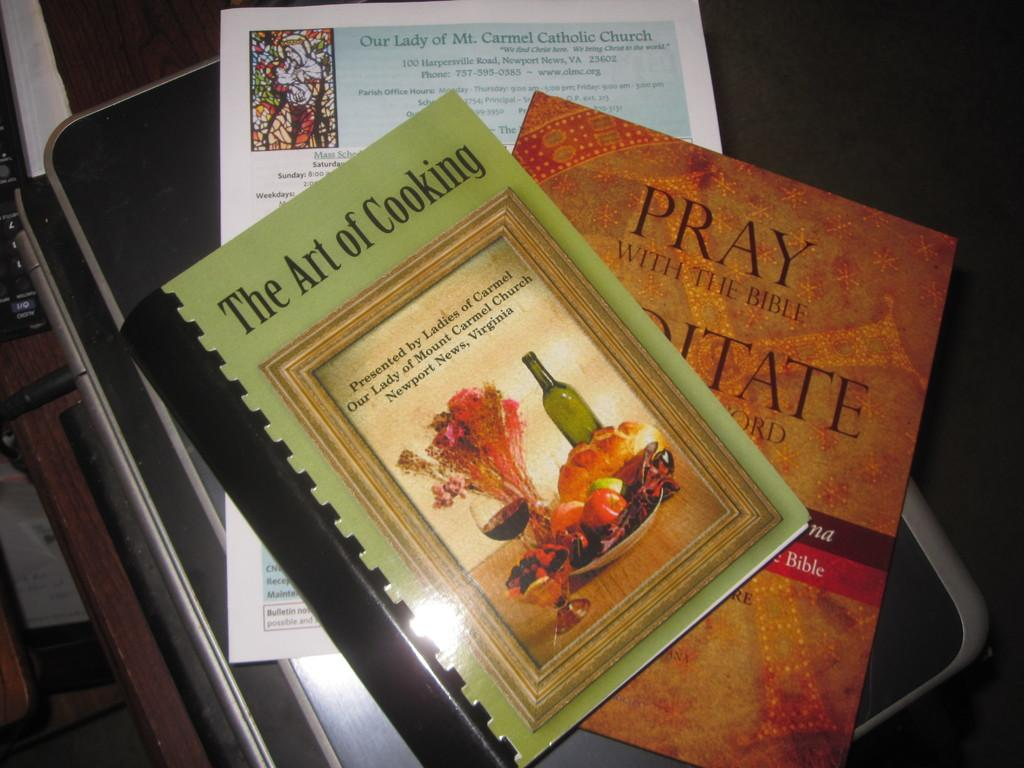<image>
Summarize the visual content of the image. Books on the Art of Cooking and Pray with the Bible. 